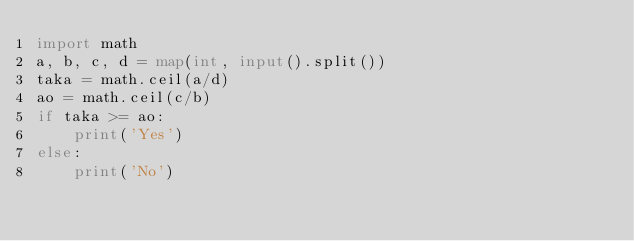<code> <loc_0><loc_0><loc_500><loc_500><_Python_>import math
a, b, c, d = map(int, input().split())
taka = math.ceil(a/d)
ao = math.ceil(c/b)
if taka >= ao:
    print('Yes')
else:
    print('No') </code> 